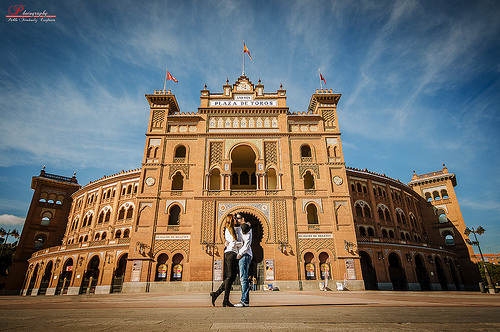<image>
Is there a flag above the couple? Yes. The flag is positioned above the couple in the vertical space, higher up in the scene. 